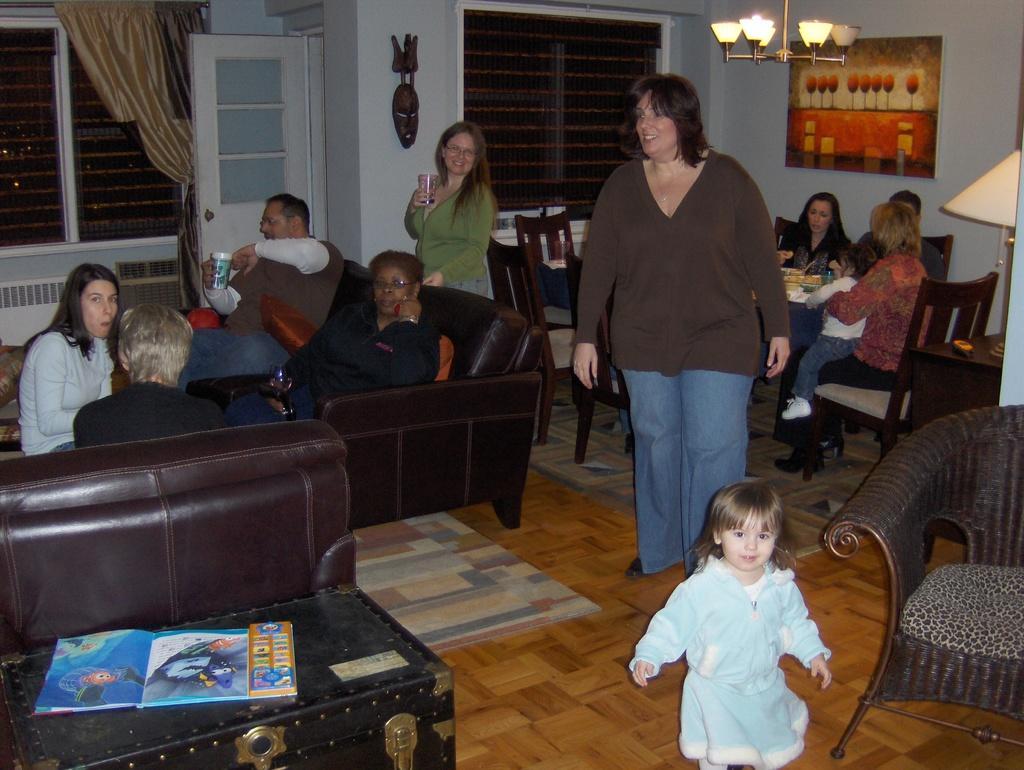Could you give a brief overview of what you see in this image? In this picture we can see some persons are sitting on the sofa. This is the floor. Here we can see some persons are sitting on the chairs. This is the light. And there is a door. Here we can see two persons standing on the floor. And there is a window. This is the curtain. Here we can see a book on the table. 